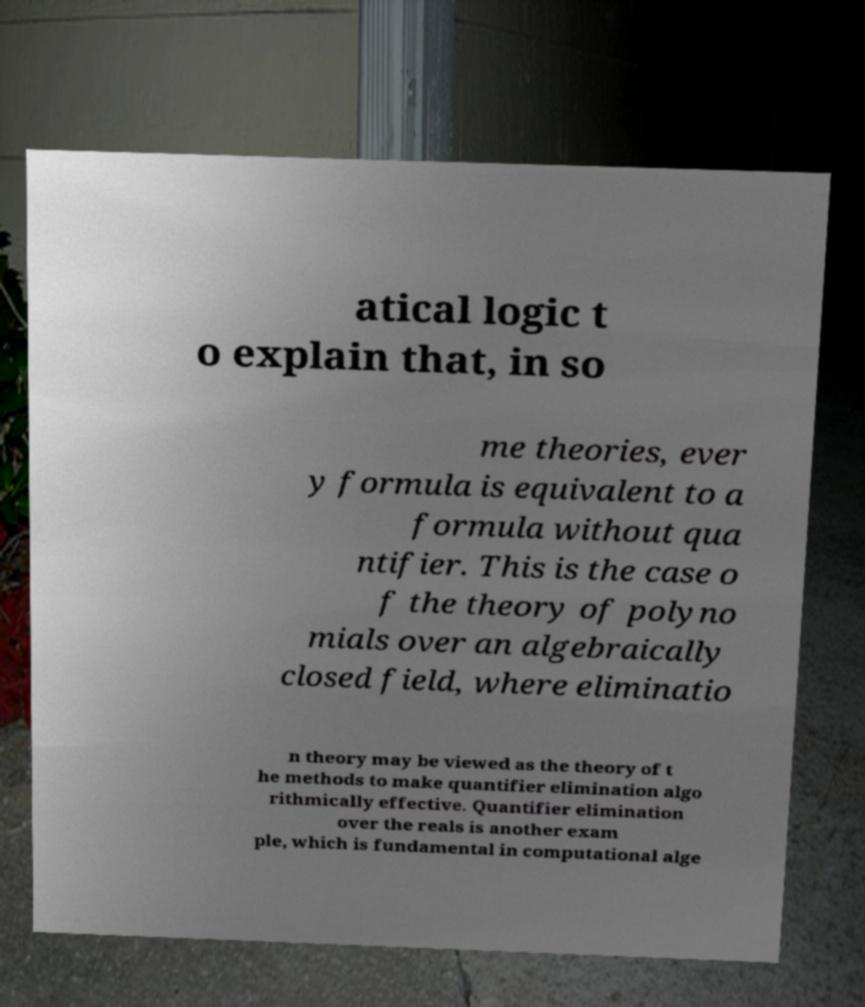Could you extract and type out the text from this image? atical logic t o explain that, in so me theories, ever y formula is equivalent to a formula without qua ntifier. This is the case o f the theory of polyno mials over an algebraically closed field, where eliminatio n theory may be viewed as the theory of t he methods to make quantifier elimination algo rithmically effective. Quantifier elimination over the reals is another exam ple, which is fundamental in computational alge 